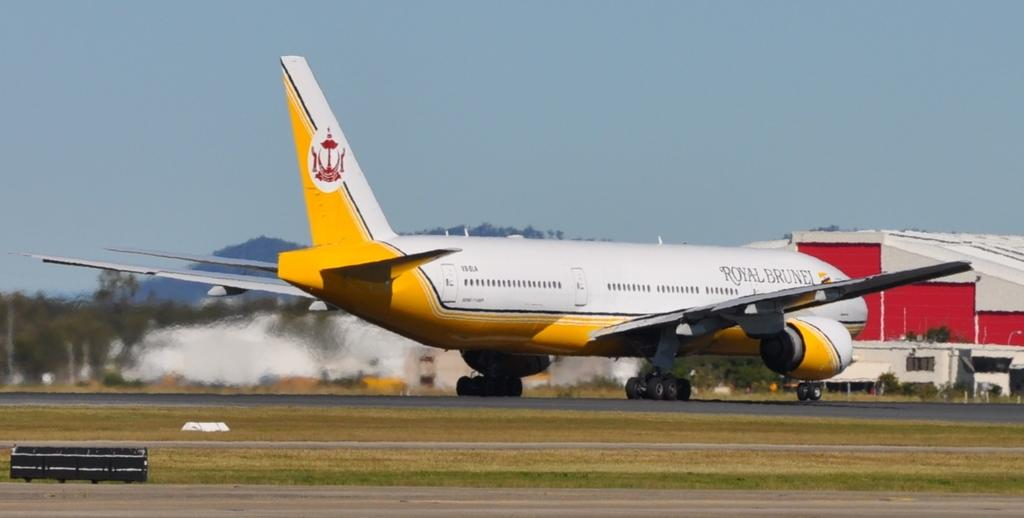Provide a one-sentence caption for the provided image. A Royal Burnel airplane is sitting on the landing area. 